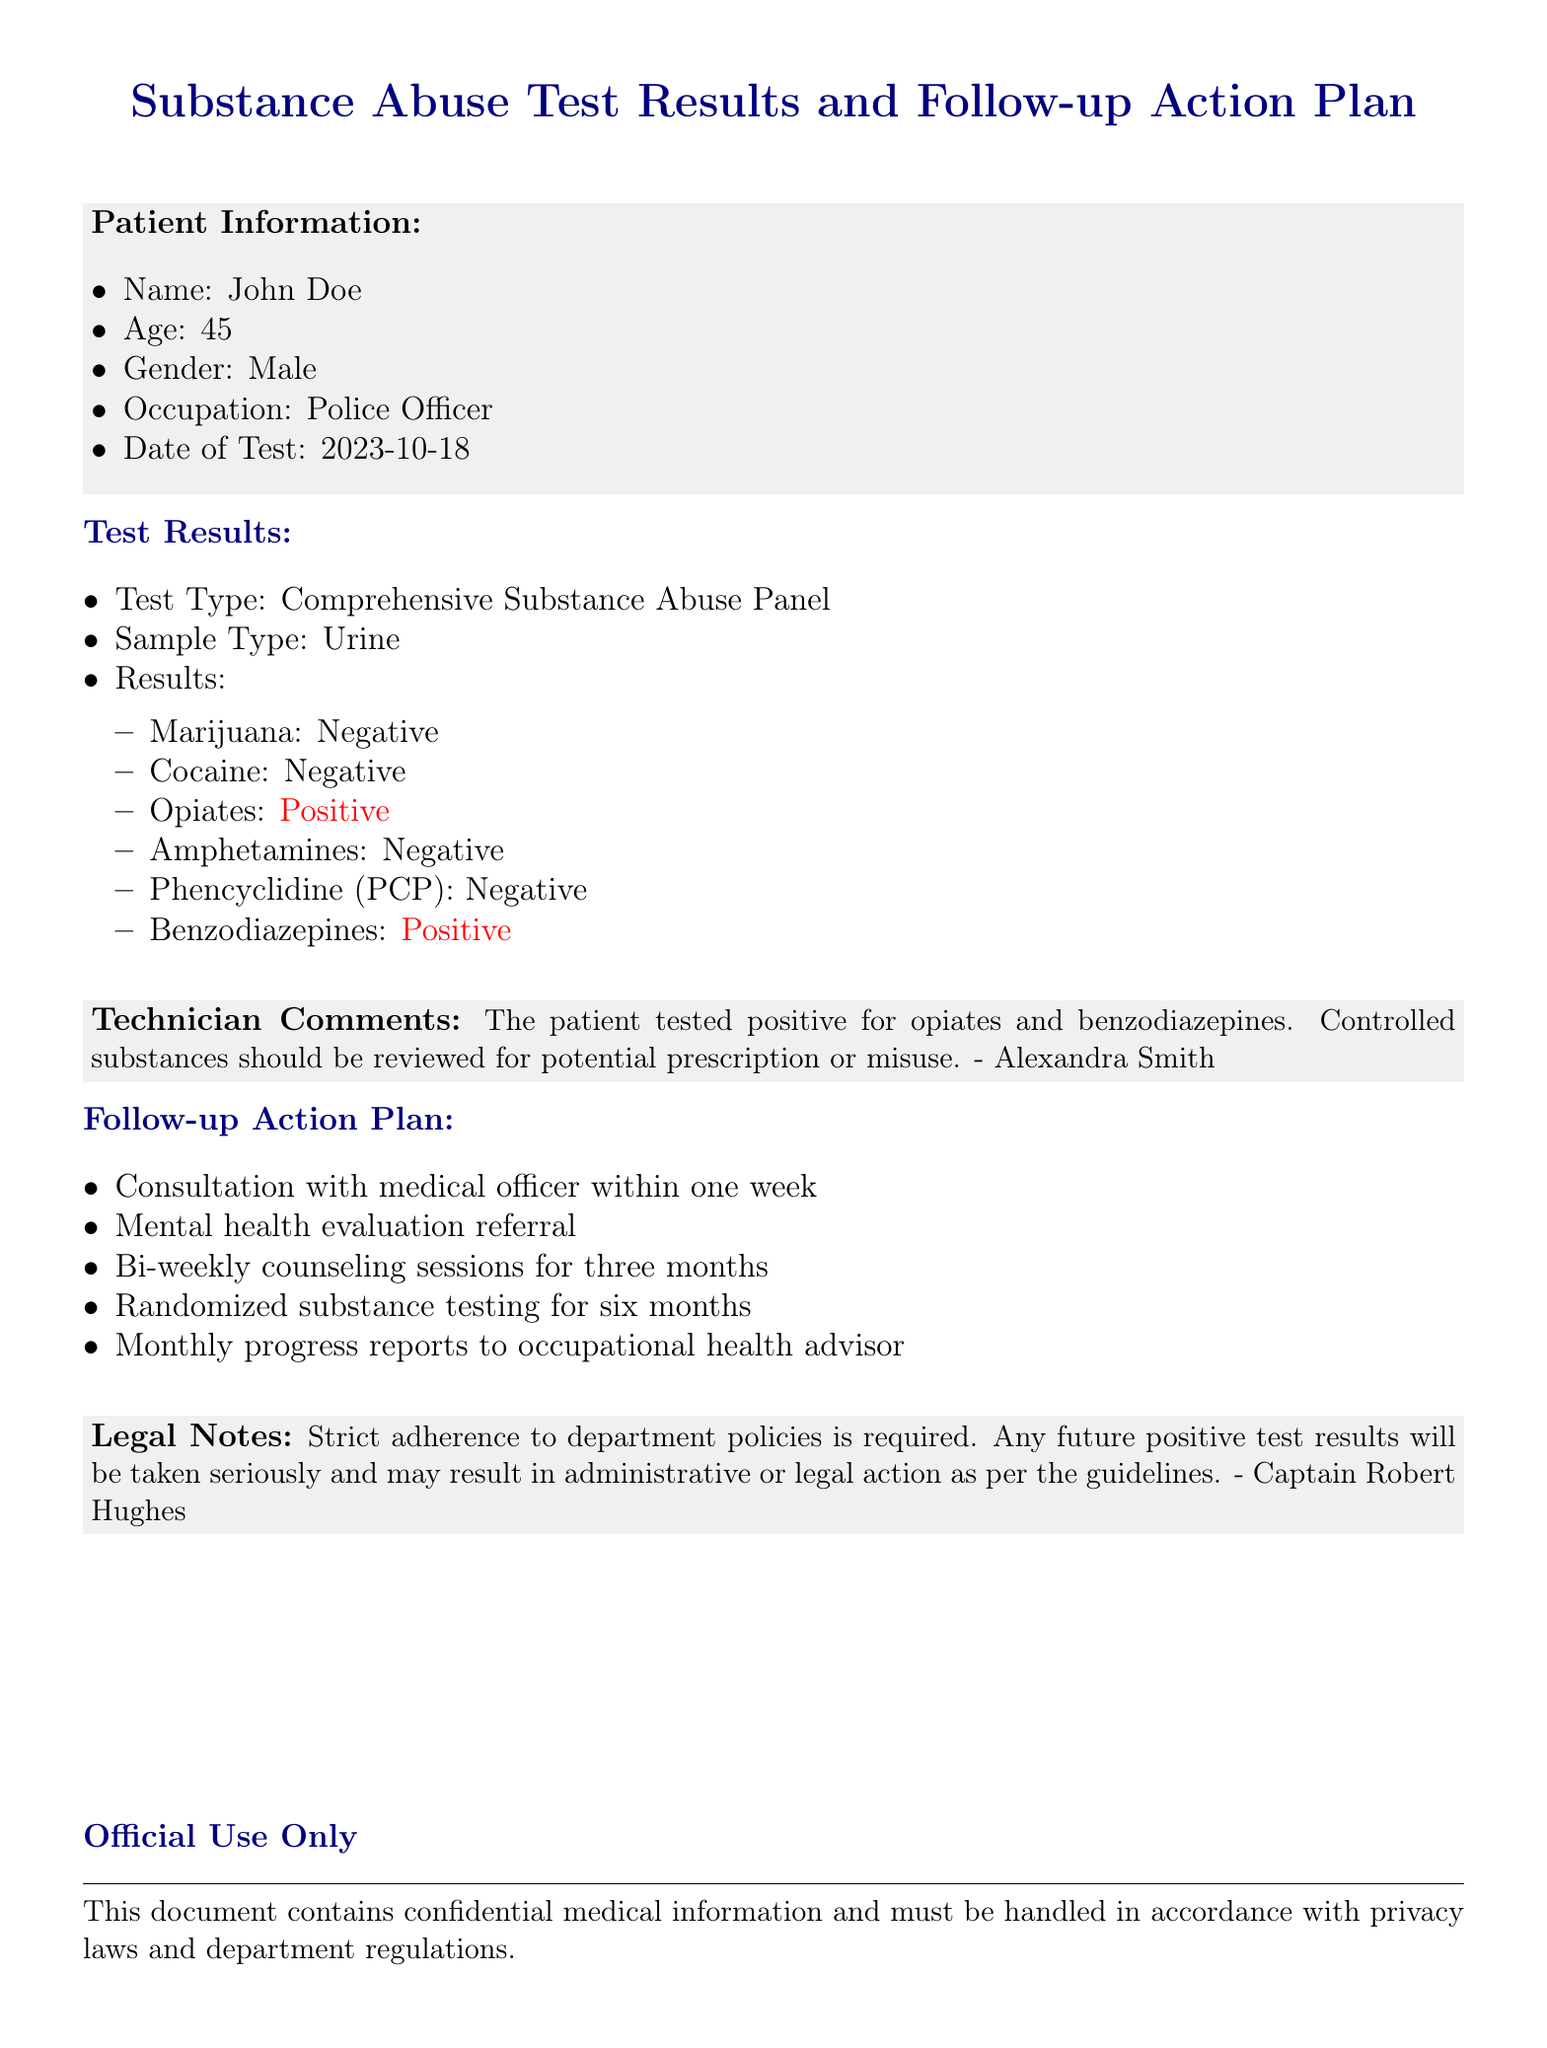What is the name of the patient? The patient's name is listed at the beginning of the document under Patient Information.
Answer: John Doe What was the date of the test? The date of the test is specified in the patient information section.
Answer: 2023-10-18 What was the result for opiates? The test result for opiates is mentioned in the Test Results section.
Answer: Positive Who performed the testing? The technician's name is mentioned in the comments section of the document.
Answer: Alexandra Smith What is the follow-up action for the patient? The Follow-up Action Plan outlines the actions to take, including specific steps.
Answer: Consultation with medical officer within one week How long is the counseling plan scheduled for? The duration of the bi-weekly counseling sessions is stated in the Follow-up Action Plan.
Answer: Three months What should be reviewed according to Technician Comments? The Technician Comments section mentions what should be reviewed regarding the patient's condition.
Answer: Controlled substances What happens to future positive test results? The Legal Notes section outlines the implications of future positive test results.
Answer: Administrative or legal action What type of substance abuse test was conducted? The Test Results section specifies the type of test performed on the patient.
Answer: Comprehensive Substance Abuse Panel 